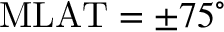Convert formula to latex. <formula><loc_0><loc_0><loc_500><loc_500>M L A T = \pm 7 5 ^ { \circ }</formula> 